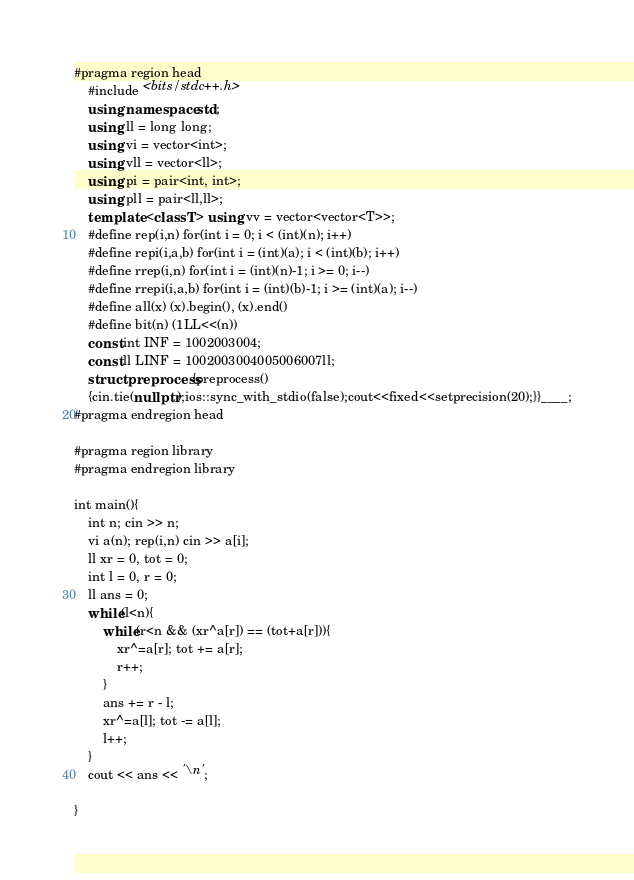Convert code to text. <code><loc_0><loc_0><loc_500><loc_500><_C++_>#pragma region head
    #include <bits/stdc++.h>
    using namespace std;
    using ll = long long;
    using vi = vector<int>;
    using vll = vector<ll>;
    using pi = pair<int, int>;
    using pll = pair<ll,ll>;
    template <class T> using vv = vector<vector<T>>;
    #define rep(i,n) for(int i = 0; i < (int)(n); i++)
    #define repi(i,a,b) for(int i = (int)(a); i < (int)(b); i++)
    #define rrep(i,n) for(int i = (int)(n)-1; i >= 0; i--)
    #define rrepi(i,a,b) for(int i = (int)(b)-1; i >= (int)(a); i--)
    #define all(x) (x).begin(), (x).end()
    #define bit(n) (1LL<<(n))
    const int INF = 1002003004;
    const ll LINF = 1002003004005006007ll;
    struct preprocess{preprocess()
    {cin.tie(nullptr);ios::sync_with_stdio(false);cout<<fixed<<setprecision(20);}}____;
#pragma endregion head

#pragma region library
#pragma endregion library

int main(){
    int n; cin >> n;
    vi a(n); rep(i,n) cin >> a[i];
    ll xr = 0, tot = 0;
    int l = 0, r = 0;
    ll ans = 0;
    while(l<n){
        while(r<n && (xr^a[r]) == (tot+a[r])){
            xr^=a[r]; tot += a[r];
            r++;
        }
        ans += r - l;
        xr^=a[l]; tot -= a[l];
        l++;
    }
    cout << ans << '\n';
    
}</code> 